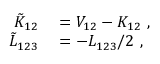Convert formula to latex. <formula><loc_0><loc_0><loc_500><loc_500>\begin{array} { r l } { \tilde { K } _ { 1 2 } } & = V _ { 1 2 } - K _ { 1 2 } , } \\ { \tilde { L } _ { 1 2 3 } } & = - L _ { 1 2 3 } / 2 , } \end{array}</formula> 